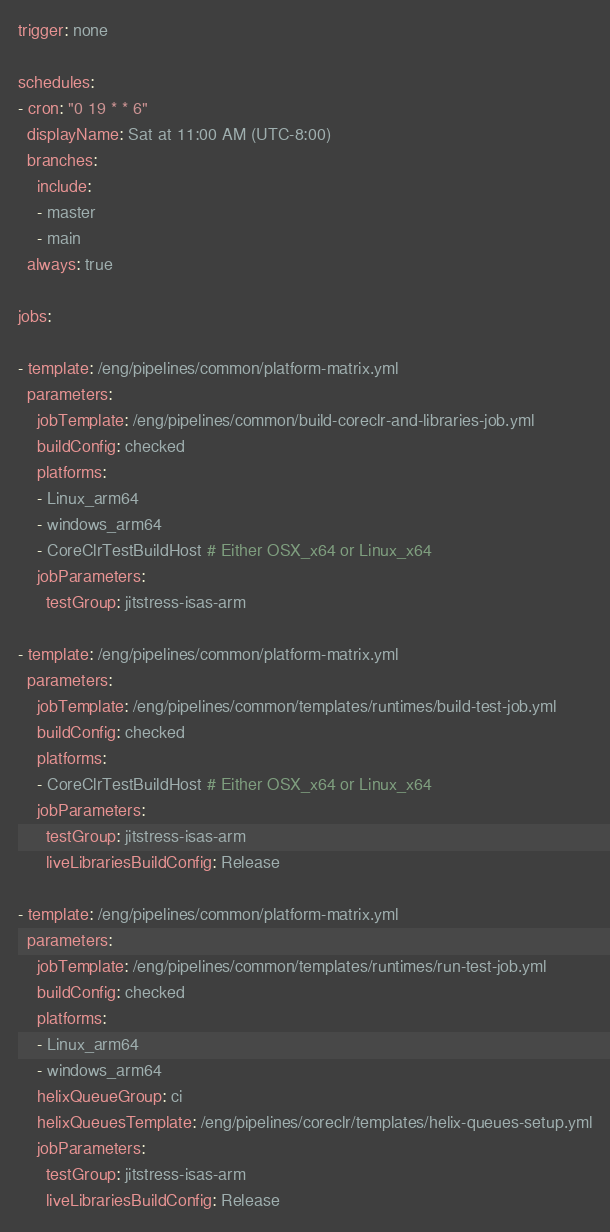<code> <loc_0><loc_0><loc_500><loc_500><_YAML_>trigger: none

schedules:
- cron: "0 19 * * 6"
  displayName: Sat at 11:00 AM (UTC-8:00)
  branches:
    include:
    - master
    - main
  always: true

jobs:

- template: /eng/pipelines/common/platform-matrix.yml
  parameters:
    jobTemplate: /eng/pipelines/common/build-coreclr-and-libraries-job.yml
    buildConfig: checked
    platforms:
    - Linux_arm64
    - windows_arm64
    - CoreClrTestBuildHost # Either OSX_x64 or Linux_x64
    jobParameters:
      testGroup: jitstress-isas-arm

- template: /eng/pipelines/common/platform-matrix.yml
  parameters:
    jobTemplate: /eng/pipelines/common/templates/runtimes/build-test-job.yml
    buildConfig: checked
    platforms:
    - CoreClrTestBuildHost # Either OSX_x64 or Linux_x64
    jobParameters:
      testGroup: jitstress-isas-arm
      liveLibrariesBuildConfig: Release

- template: /eng/pipelines/common/platform-matrix.yml
  parameters:
    jobTemplate: /eng/pipelines/common/templates/runtimes/run-test-job.yml
    buildConfig: checked
    platforms:
    - Linux_arm64
    - windows_arm64
    helixQueueGroup: ci
    helixQueuesTemplate: /eng/pipelines/coreclr/templates/helix-queues-setup.yml
    jobParameters:
      testGroup: jitstress-isas-arm
      liveLibrariesBuildConfig: Release
</code> 